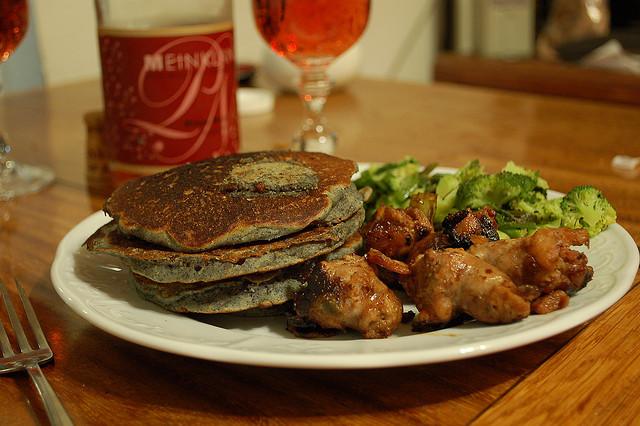What is in the jar?
Answer briefly. Wine. What side was ordered?
Give a very brief answer. Broccoli. How many forks are there?
Write a very short answer. 1. Is this a plain plate?
Be succinct. Yes. How many pancakes are there?
Quick response, please. 3. Could that be chili?
Concise answer only. No. What is the plate sitting on?
Answer briefly. Table. What are the people drinking?
Concise answer only. Wine. What food is this?
Give a very brief answer. Chicken. Is there coffee in the flowered cup?
Write a very short answer. No. What type of food is this?
Answer briefly. Dinner. What kind of food is this?
Answer briefly. Chicken. What is the shape of the table?
Short answer required. Square. What type of green vegetable is on the plates?
Quick response, please. Broccoli. What is she drinking?
Write a very short answer. Wine. Is this in a restaurant?
Give a very brief answer. Yes. What is the wall make out of?
Concise answer only. Plaster. Where is the fork?
Concise answer only. On table. What color wine is in the glass?
Be succinct. Red. How many tines does the fork have?
Quick response, please. 3. How many forks are in the photo?
Give a very brief answer. 1. How many plates are there?
Give a very brief answer. 1. Did a lot of work go into making this meal?
Concise answer only. Yes. What food is on the plate?
Quick response, please. Pancakes. Is this an outdoors scene?
Be succinct. No. What kind of meat?
Write a very short answer. Chicken. What type of food is on the plate?
Quick response, please. Pancakes and vegetables. What liquid in this picture can you get in a bottle?
Answer briefly. Wine. 